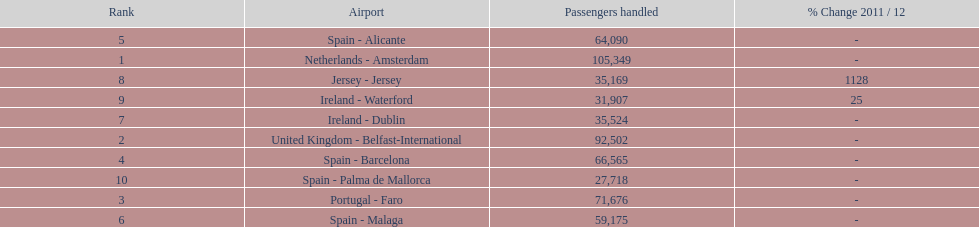How many airports in spain are among the 10 busiest routes to and from london southend airport in 2012? 4. 